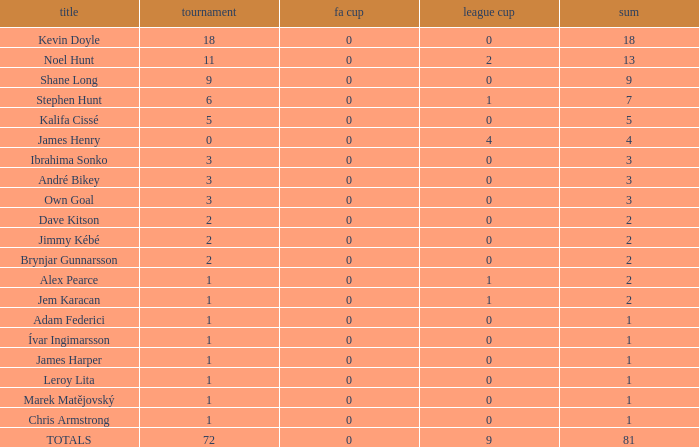What is the championship of Jem Karacan that has a total of 2 and a league cup more than 0? 1.0. 